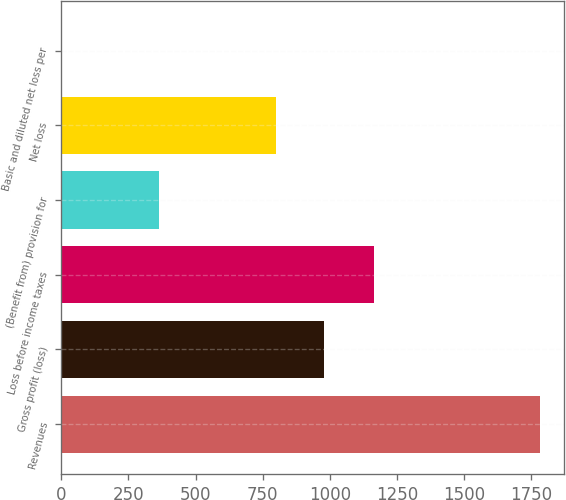<chart> <loc_0><loc_0><loc_500><loc_500><bar_chart><fcel>Revenues<fcel>Gross profit (loss)<fcel>Loss before income taxes<fcel>(Benefit from) provision for<fcel>Net loss<fcel>Basic and diluted net loss per<nl><fcel>1782.4<fcel>977.89<fcel>1165.2<fcel>365.3<fcel>799.9<fcel>2.53<nl></chart> 